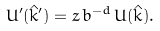<formula> <loc_0><loc_0><loc_500><loc_500>U ^ { \prime } ( { \hat { k } } ^ { \prime } ) = z \, b ^ { - d } \, U ( { \hat { k } } ) .</formula> 